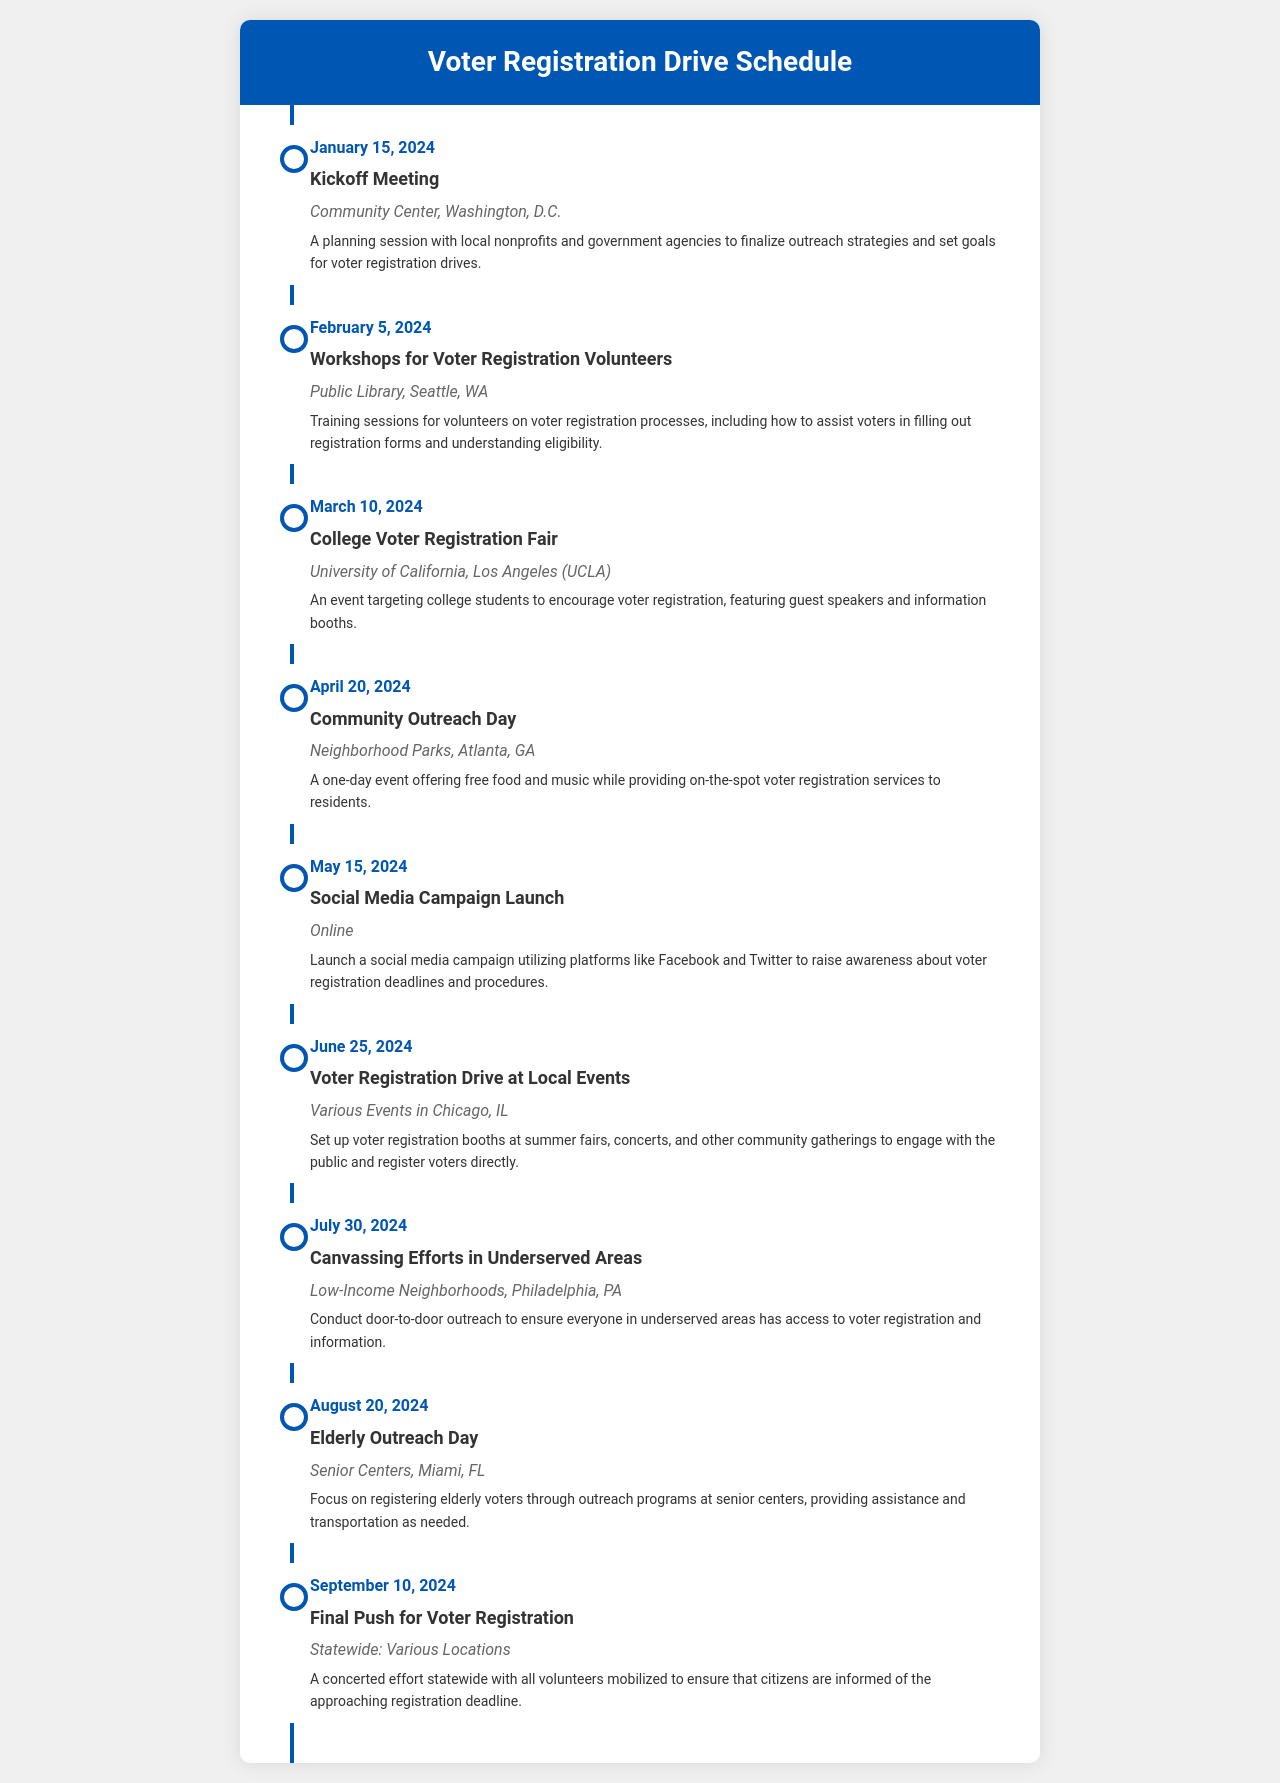What is the date of the kickoff meeting? The date of the kickoff meeting is listed as January 15, 2024.
Answer: January 15, 2024 What is the location of the College Voter Registration Fair? The College Voter Registration Fair is located at the University of California, Los Angeles (UCLA).
Answer: University of California, Los Angeles (UCLA) How many outreach activities are scheduled for the month of April? In April, there is one outreach activity listed: the Community Outreach Day on April 20, 2024.
Answer: 1 What type of event occurs on July 30, 2024? The event on July 30, 2024, is canvassing efforts in underserved areas.
Answer: Canvassing efforts in underserved areas Which social media platforms will the campaign utilize? The social media campaign will utilize platforms like Facebook and Twitter.
Answer: Facebook and Twitter What is the primary focus of the Elderly Outreach Day? The primary focus of the Elderly Outreach Day is to register elderly voters at senior centers.
Answer: Register elderly voters Which month has the final push for voter registration event? The final push for voter registration event is scheduled for September 10, 2024.
Answer: September What is the event on June 25, 2024, about? The event on June 25, 2024, is about setting up voter registration booths at local events.
Answer: Setting up voter registration booths at local events 